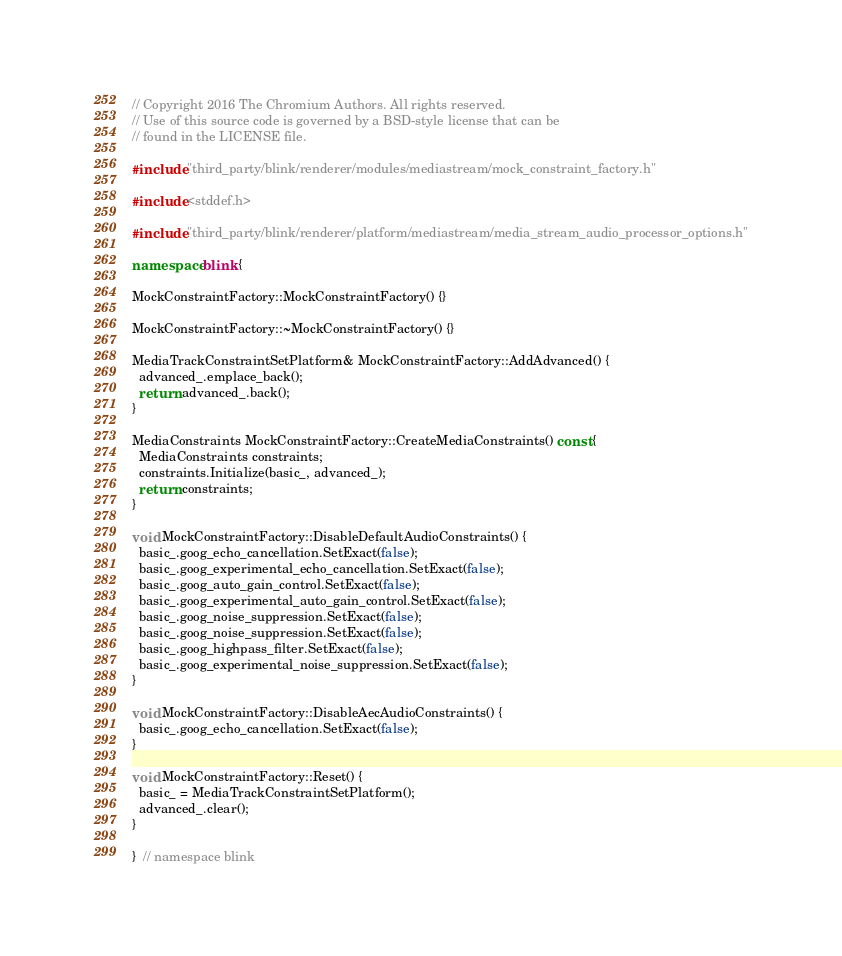<code> <loc_0><loc_0><loc_500><loc_500><_C++_>// Copyright 2016 The Chromium Authors. All rights reserved.
// Use of this source code is governed by a BSD-style license that can be
// found in the LICENSE file.

#include "third_party/blink/renderer/modules/mediastream/mock_constraint_factory.h"

#include <stddef.h>

#include "third_party/blink/renderer/platform/mediastream/media_stream_audio_processor_options.h"

namespace blink {

MockConstraintFactory::MockConstraintFactory() {}

MockConstraintFactory::~MockConstraintFactory() {}

MediaTrackConstraintSetPlatform& MockConstraintFactory::AddAdvanced() {
  advanced_.emplace_back();
  return advanced_.back();
}

MediaConstraints MockConstraintFactory::CreateMediaConstraints() const {
  MediaConstraints constraints;
  constraints.Initialize(basic_, advanced_);
  return constraints;
}

void MockConstraintFactory::DisableDefaultAudioConstraints() {
  basic_.goog_echo_cancellation.SetExact(false);
  basic_.goog_experimental_echo_cancellation.SetExact(false);
  basic_.goog_auto_gain_control.SetExact(false);
  basic_.goog_experimental_auto_gain_control.SetExact(false);
  basic_.goog_noise_suppression.SetExact(false);
  basic_.goog_noise_suppression.SetExact(false);
  basic_.goog_highpass_filter.SetExact(false);
  basic_.goog_experimental_noise_suppression.SetExact(false);
}

void MockConstraintFactory::DisableAecAudioConstraints() {
  basic_.goog_echo_cancellation.SetExact(false);
}

void MockConstraintFactory::Reset() {
  basic_ = MediaTrackConstraintSetPlatform();
  advanced_.clear();
}

}  // namespace blink
</code> 